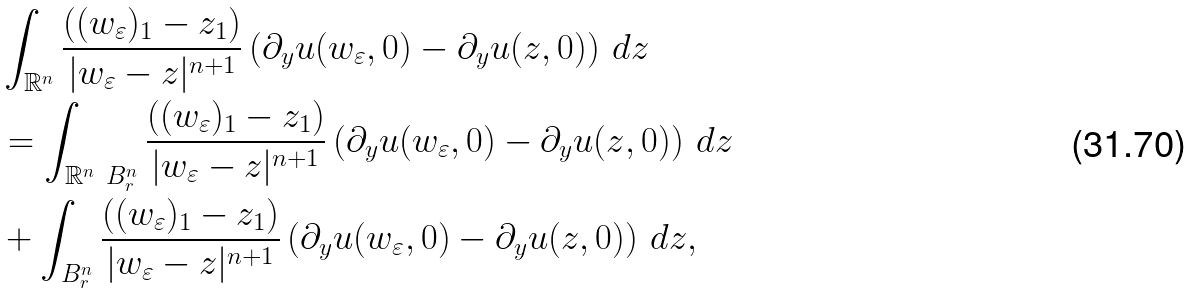<formula> <loc_0><loc_0><loc_500><loc_500>& \int _ { \mathbb { R } ^ { n } } \frac { ( ( w _ { \varepsilon } ) _ { 1 } - z _ { 1 } ) } { | w _ { \varepsilon } - z | ^ { n + 1 } } \left ( \partial _ { y } u ( w _ { \varepsilon } , 0 ) - \partial _ { y } u ( z , 0 ) \right ) \, d z \\ & = \int _ { \mathbb { R } ^ { n } \ B ^ { n } _ { r } } \frac { ( ( w _ { \varepsilon } ) _ { 1 } - z _ { 1 } ) } { | w _ { \varepsilon } - z | ^ { n + 1 } } \left ( \partial _ { y } u ( w _ { \varepsilon } , 0 ) - \partial _ { y } u ( z , 0 ) \right ) \, d z \\ & + \int _ { B ^ { n } _ { r } } \frac { ( ( w _ { \varepsilon } ) _ { 1 } - z _ { 1 } ) } { | w _ { \varepsilon } - z | ^ { n + 1 } } \left ( \partial _ { y } u ( w _ { \varepsilon } , 0 ) - \partial _ { y } u ( z , 0 ) \right ) \, d z ,</formula> 